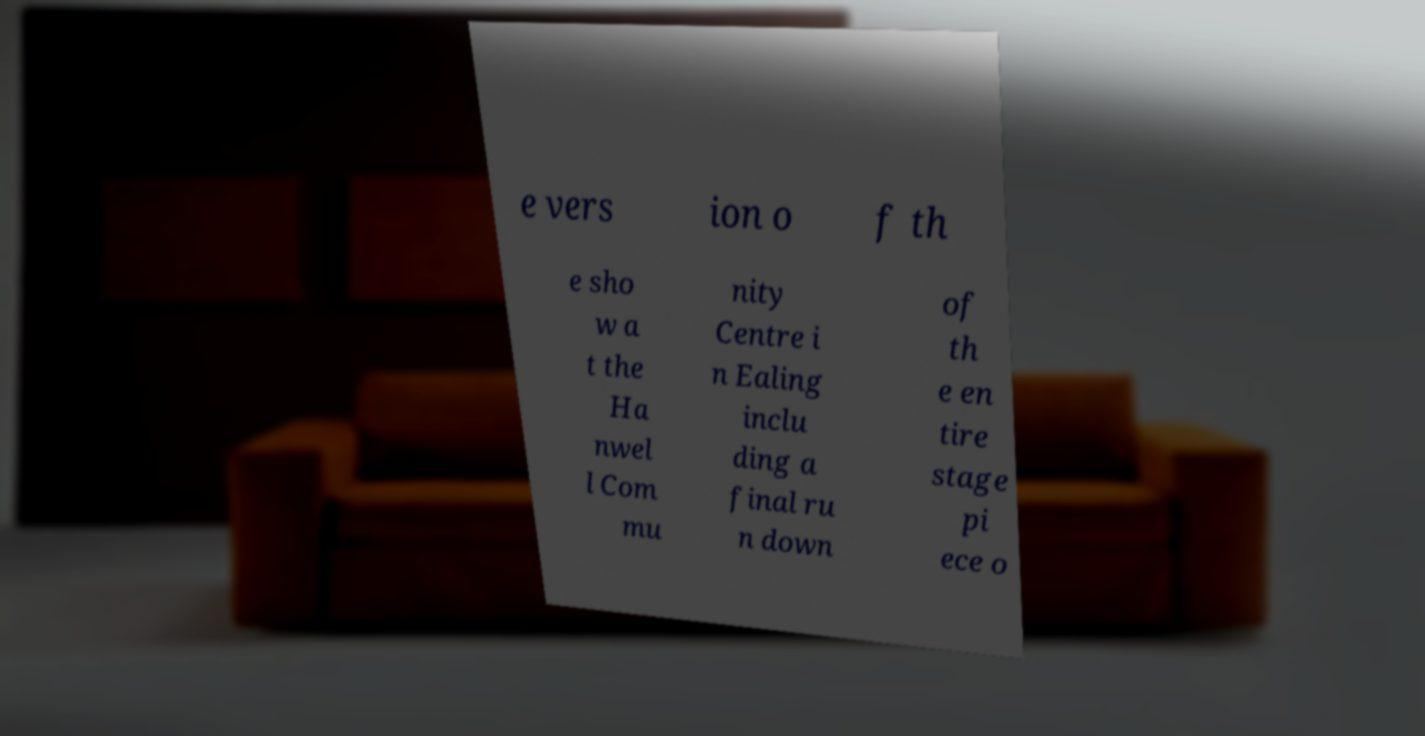Can you read and provide the text displayed in the image?This photo seems to have some interesting text. Can you extract and type it out for me? e vers ion o f th e sho w a t the Ha nwel l Com mu nity Centre i n Ealing inclu ding a final ru n down of th e en tire stage pi ece o 